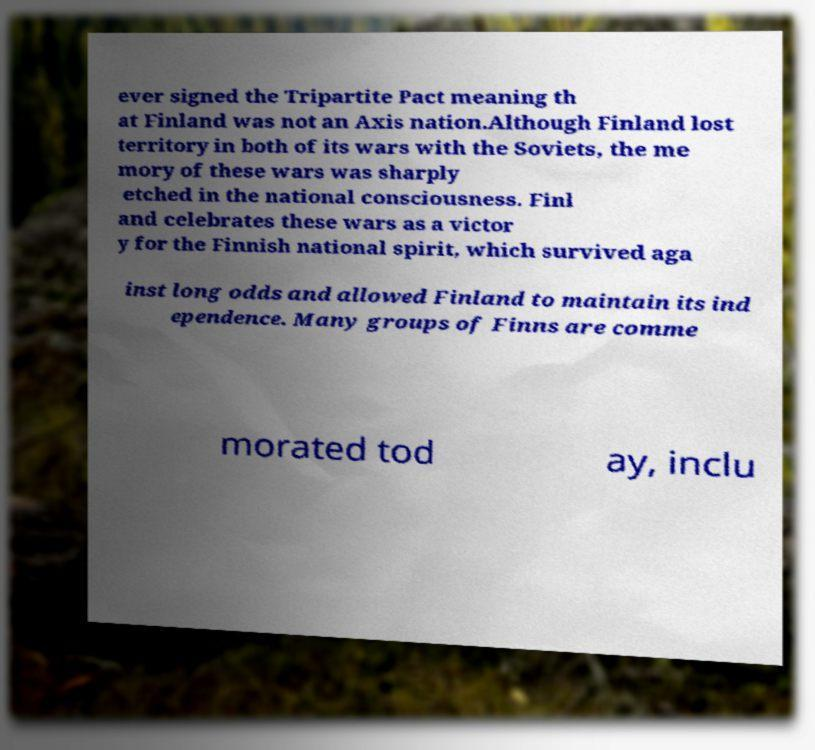Please identify and transcribe the text found in this image. ever signed the Tripartite Pact meaning th at Finland was not an Axis nation.Although Finland lost territory in both of its wars with the Soviets, the me mory of these wars was sharply etched in the national consciousness. Finl and celebrates these wars as a victor y for the Finnish national spirit, which survived aga inst long odds and allowed Finland to maintain its ind ependence. Many groups of Finns are comme morated tod ay, inclu 